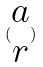<formula> <loc_0><loc_0><loc_500><loc_500>( \begin{matrix} a \\ r \end{matrix} )</formula> 